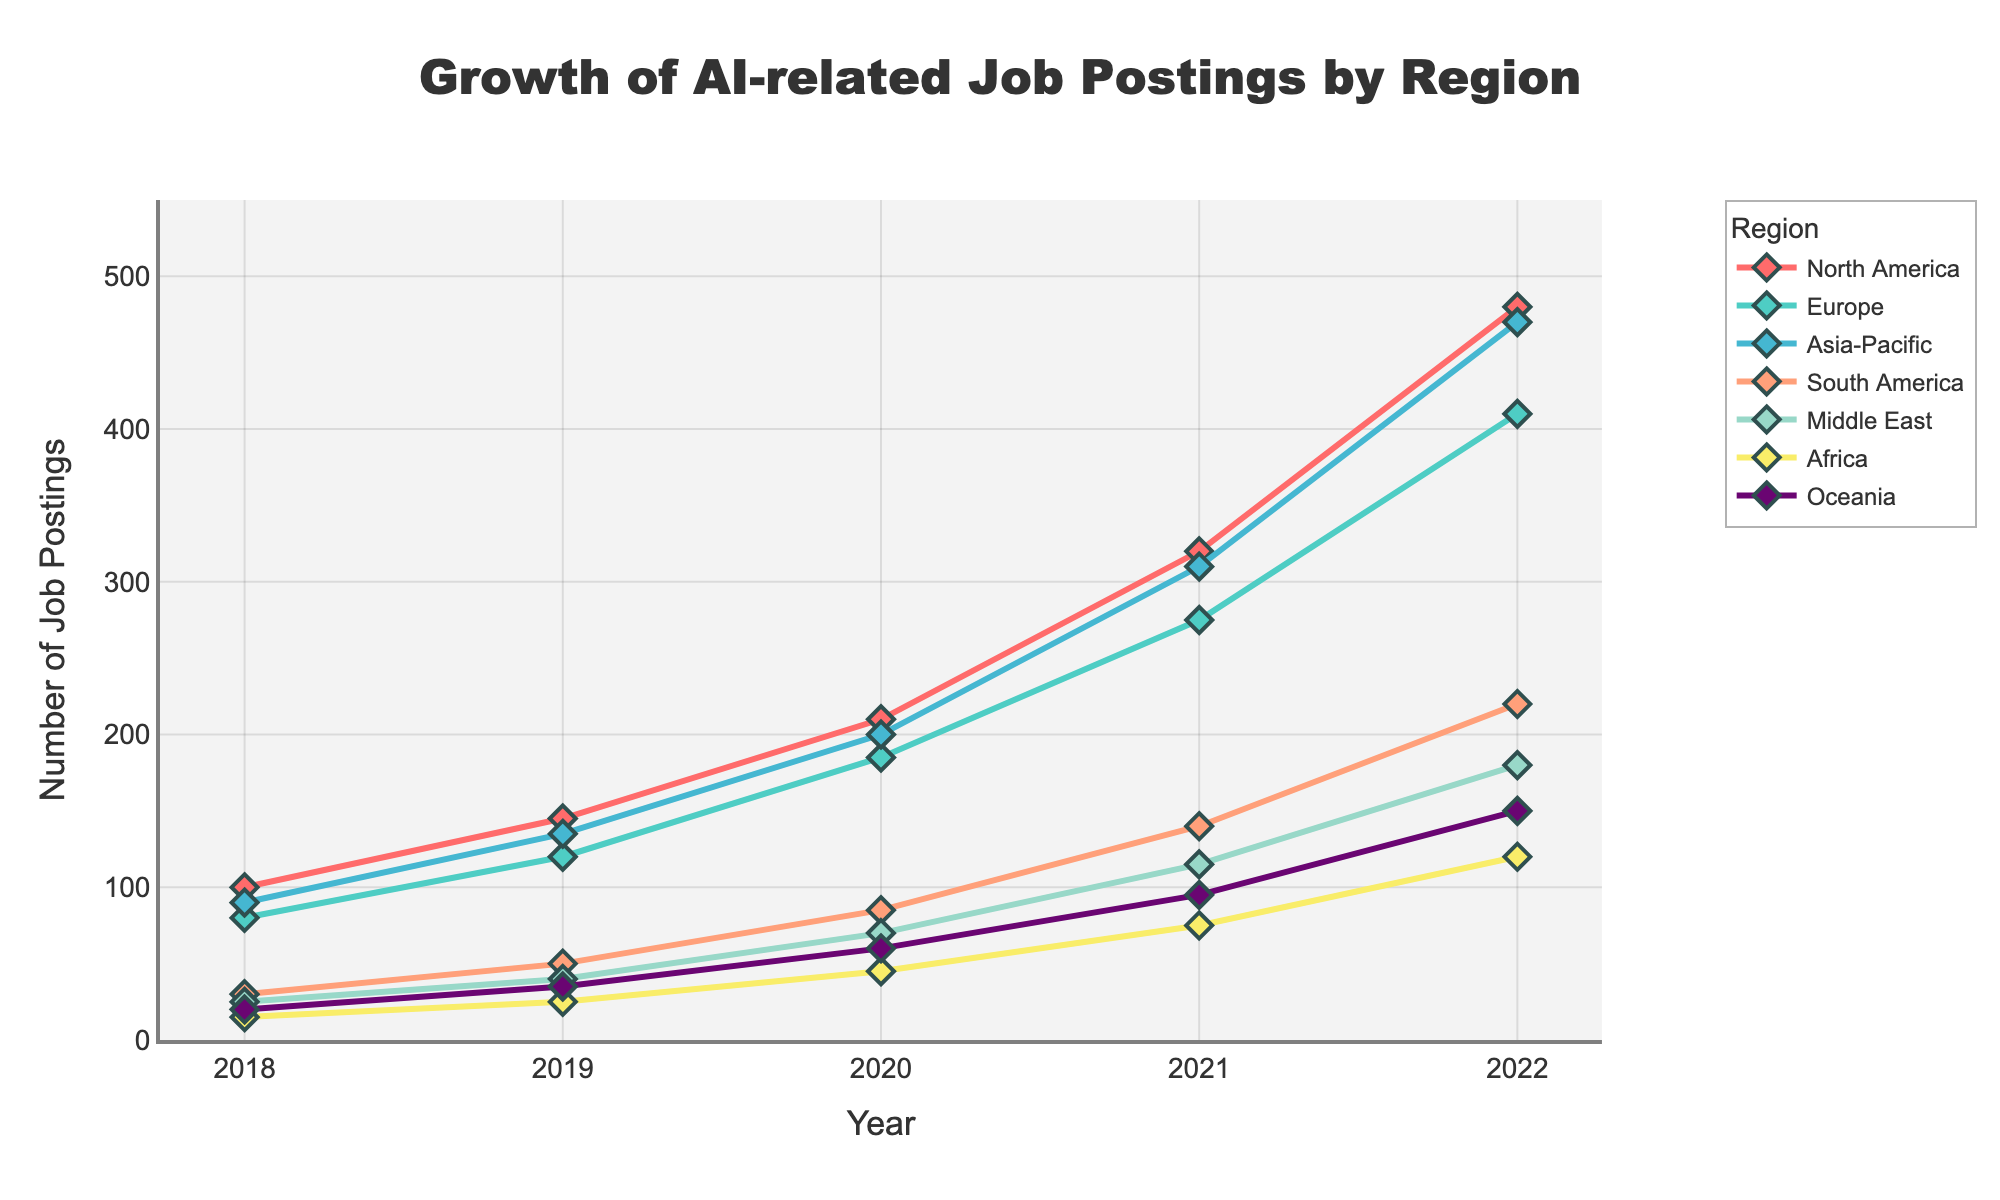What was the total number of AI-related job postings across all regions in 2022? To find the total number of job postings across all regions in 2022, sum the values for each region in that year. The values are 480 (North America) + 410 (Europe) + 470 (Asia-Pacific) + 220 (South America) + 180 (Middle East) + 120 (Africa) + 150 (Oceania). The sum is 2030.
Answer: 2030 Which region had the highest growth in AI-related job postings from 2018 to 2022? To find which region had the highest growth, you need to subtract the job postings in 2018 from those in 2022 for each region. The differences are: North America (480 - 100 = 380), Europe (410 - 80 = 330), Asia-Pacific (470 - 90 = 380), South America (220 - 30 = 190), Middle East (180 - 25 = 155), Africa (120 - 15 = 105), Oceania (150 - 20 = 130). Both North America and Asia-Pacific show the highest growth with 380 each.
Answer: North America and Asia-Pacific By how many job postings did Asia-Pacific surpass Europe in 2022? To find how many job postings Asia-Pacific surpassed Europe by in 2022, subtract the number of postings in Europe from those in Asia-Pacific. In 2022, Asia-Pacific had 470 postings and Europe had 410, so 470 - 410 = 60.
Answer: 60 Which years did Europe and North America have the same number of job postings in any year? Compare the job postings for Europe and North America year by year. Only in 2018, Europe had 80 job postings and North America had 100 job postings which are different. They did not have the same number of job postings in any year.
Answer: None What is the percent increase in AI-related job postings for South America from 2018 to 2022? Calculate the percent increase by subtracting the initial value from the final value, dividing by the initial value, and then multiplying by 100. (220 - 30) / 30 * 100 = 633.33%.
Answer: 633.33% How does the job growth trend in Middle East compare visually to that in Oceania over the 5-year period? Visually inspect the slopes of the lines representing Middle East and Oceania. The Middle East line starts lower and has a slightly steeper slope than Oceania. This suggests that both regions have increasing trends, but the growth rate in the Middle East is marginally higher compared to Oceania.
Answer: Middle East has a slightly steeper trend What is the average number of AI-related job postings in Africa from 2018 to 2022? To find the average, sum the number of job postings for Africa over the five years and then divide by 5. (15 + 25 + 45 + 75 + 120) / 5 = 280 / 5 = 56.
Answer: 56 What visual marker is used to represent data points on the line chart? After inspecting the figure, it is evident that the data points on the line chart are represented using diamond-shaped markers.
Answer: Diamond Between which consecutive years did Europe experience the highest increase in job postings? Calculate the increase in job postings for consecutive years and find which year interval had the highest value. For Europe: 2018-2019 (120 - 80 = 40), 2019-2020 (185 - 120 = 65), 2020-2021 (275 - 185 = 90), 2021-2022 (410 - 275 = 135). The highest increase occurred between 2021-2022.
Answer: 2021-2022 